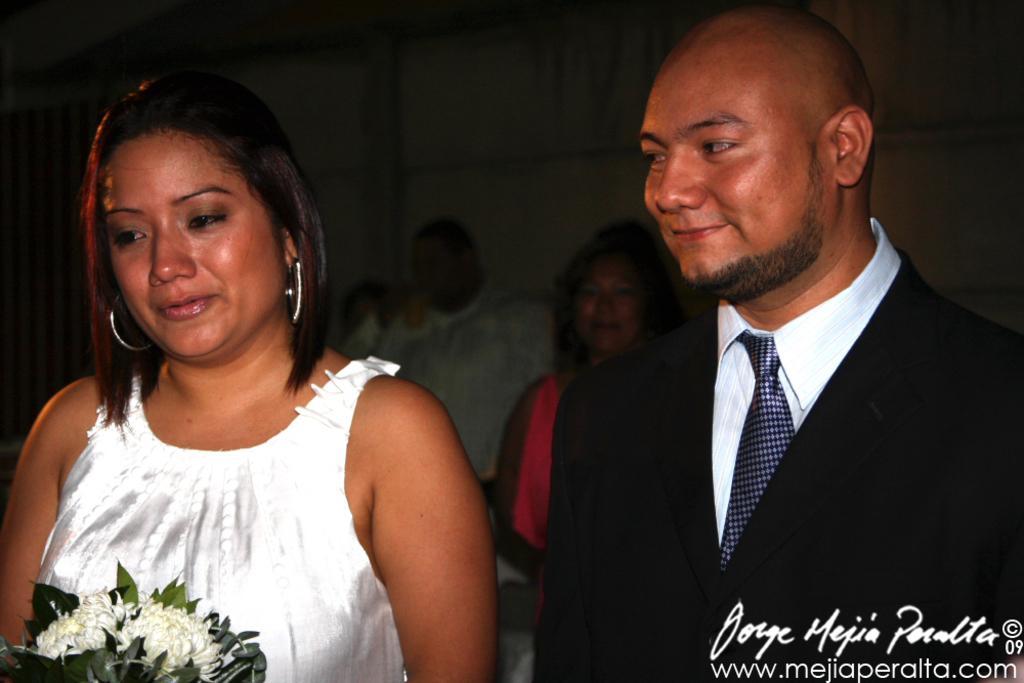How would you summarize this image in a sentence or two? In this image there are people one wearing white top and holding a flower vase and the other person wearing a black coat in the foreground. And there are people in the background. 